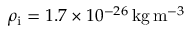Convert formula to latex. <formula><loc_0><loc_0><loc_500><loc_500>\rho _ { i } = 1 . 7 \times 1 0 ^ { - 2 6 } \, k g \, m ^ { - 3 }</formula> 